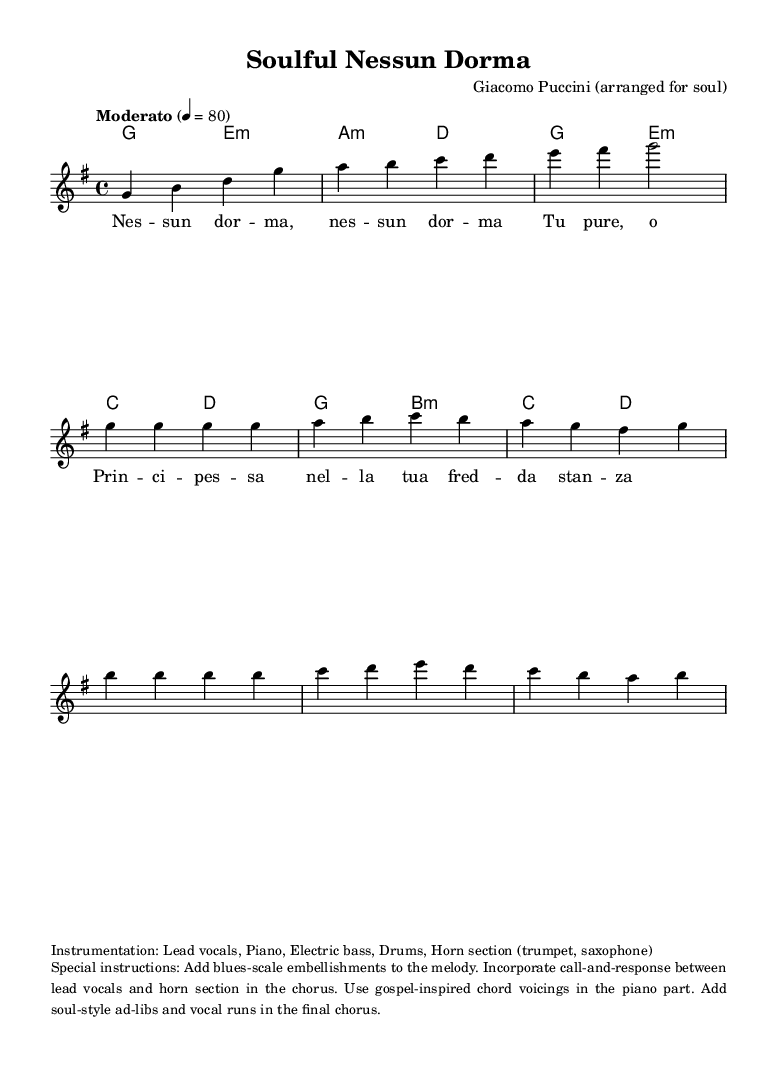What is the key signature of this music? The key signature is G major, which has one sharp (F#). This can be identified at the beginning of the score where the key signature is indicated.
Answer: G major What is the time signature of this music? The time signature is 4/4, as noted at the beginning of the score. This means there are four beats per measure and the quarter note receives one beat.
Answer: 4/4 What tempo marking is indicated for this piece? The tempo marking given is "Moderato," which suggests a moderate pace. The metronome marking of 80 also indicates the beats per minute to play at.
Answer: Moderato How many measures are in the introduction? The introduction consists of 4 measures as it is shown in the notation before the verse starts. Counting the intro section confirms this.
Answer: 4 What type of chord voicings are suggested for the piano part? The special instructions note to use gospel-inspired chord voicings. This means the chords should be richer and aim for a fuller, soulful sound specific to the gospel style.
Answer: Gospel-inspired What instruments are specified for the instrumentation? The specified instrumentation includes lead vocals, piano, electric bass, drums, and a horn section (trumpet, saxophone). This list indicates a small ensemble typical in Soul music.
Answer: Lead vocals, Piano, Electric bass, Drums, Horn section What type of embellishments are suggested for the melody? The special instructions indicate to add blues-scale embellishments to the melody, which will enhance its soulful character by incorporating typical blues notes and phrases.
Answer: Blues-scale embellishments 